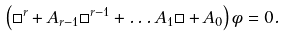Convert formula to latex. <formula><loc_0><loc_0><loc_500><loc_500>\left ( \square ^ { r } + A _ { r - 1 } \square ^ { r - 1 } + \dots A _ { 1 } \square + A _ { 0 } \right ) \phi = 0 .</formula> 